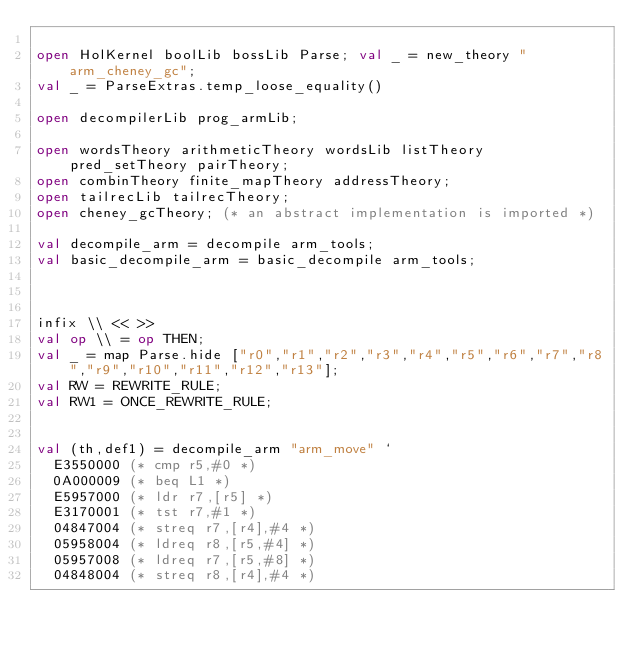Convert code to text. <code><loc_0><loc_0><loc_500><loc_500><_SML_>
open HolKernel boolLib bossLib Parse; val _ = new_theory "arm_cheney_gc";
val _ = ParseExtras.temp_loose_equality()

open decompilerLib prog_armLib;

open wordsTheory arithmeticTheory wordsLib listTheory pred_setTheory pairTheory;
open combinTheory finite_mapTheory addressTheory;
open tailrecLib tailrecTheory;
open cheney_gcTheory; (* an abstract implementation is imported *)

val decompile_arm = decompile arm_tools;
val basic_decompile_arm = basic_decompile arm_tools;



infix \\ << >>
val op \\ = op THEN;
val _ = map Parse.hide ["r0","r1","r2","r3","r4","r5","r6","r7","r8","r9","r10","r11","r12","r13"];
val RW = REWRITE_RULE;
val RW1 = ONCE_REWRITE_RULE;


val (th,def1) = decompile_arm "arm_move" `
  E3550000 (* cmp r5,#0 *)
  0A000009 (* beq L1 *)
  E5957000 (* ldr r7,[r5] *)
  E3170001 (* tst r7,#1 *)
  04847004 (* streq r7,[r4],#4 *)
  05958004 (* ldreq r8,[r5,#4] *)
  05957008 (* ldreq r7,[r5,#8] *)
  04848004 (* streq r8,[r4],#4 *)</code> 